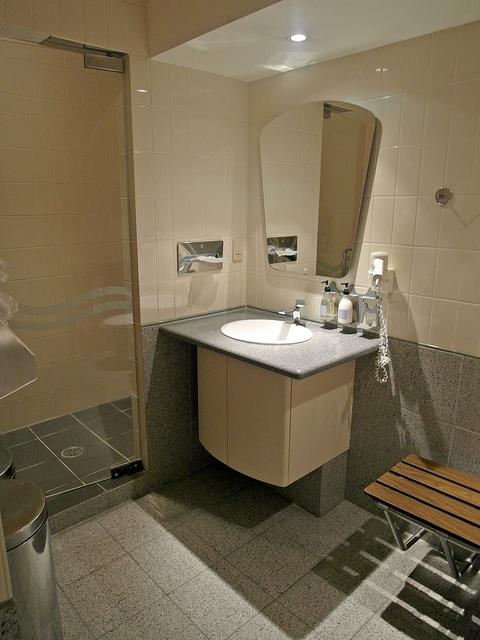What usually happens in this room? Please explain your reasoning. hand washing. You can wash your hands at the sink. you can also use the shower to clean your body off. 